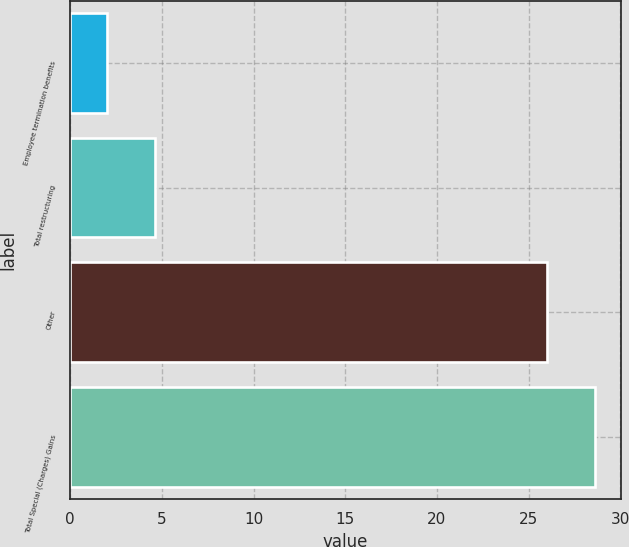Convert chart to OTSL. <chart><loc_0><loc_0><loc_500><loc_500><bar_chart><fcel>Employee termination benefits<fcel>Total restructuring<fcel>Other<fcel>Total Special (Charges) Gains<nl><fcel>2<fcel>4.6<fcel>26<fcel>28.6<nl></chart> 